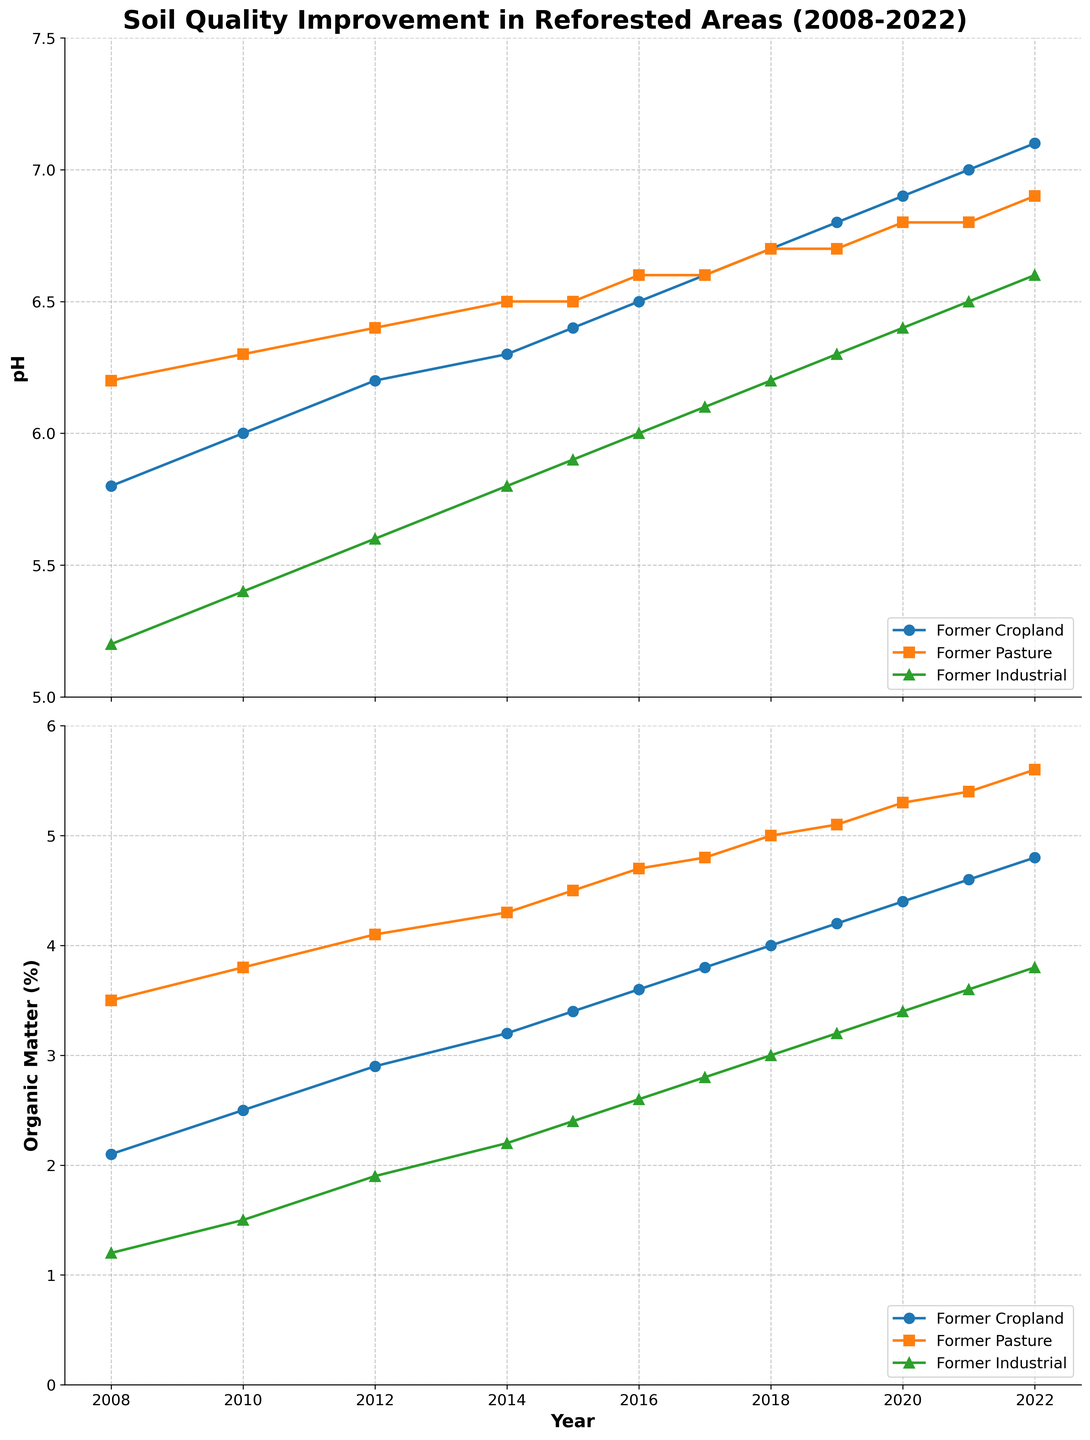What is the trend of soil pH in former cropland from 2008 to 2022? The trend can be observed by looking at the pH values on the line chart for former cropland over the years. The pH values start at 5.8 in 2008 and gradually increase each year, reaching 7.1 in 2022.
Answer: Increasing How does the organic matter percentage trend in former industrial areas from 2008 to 2022? To determine the trend, we observe the line representing the organic matter percentage in former industrial areas. It starts at 1.2% in 2008 and consistently rises each year, reaching 3.8% in 2022.
Answer: Increasing Which category had the highest increase in organic matter percentage from 2008 to 2022? To find this, we calculate the difference in organic matter percentage between 2008 and 2022 for each category. Former Cropland increased from 2.1% to 4.8% (2.7%), Former Pasture increased from 3.5% to 5.6% (2.1%), and Former Industrial increased from 1.2% to 3.8% (2.6%). Former Cropland shows the highest increase.
Answer: Former Cropland Between 2010 and 2014, which land use type showed the smallest change in pH values? We need to look at the pH values for each category in 2010 and 2014 and calculate the difference. Former Cropland: 6.0 to 6.3 (0.3), Former Pasture: 6.3 to 6.5 (0.2), Former Industrial: 5.4 to 5.8 (0.4). Former Pasture has the smallest change.
Answer: Former Pasture What was the pH of former industrial lands in 2015, and how does it compare to former pasturelands in the same year? Checking the pH values from the figure for both categories in 2015: Former Industrial is at 5.9, and Former Pasture is at 6.5. Comparing them, 5.9 is less than 6.5.
Answer: 5.9, less than In 2020, which land type had a higher percentage of organic matter, former cropland or former pasture? Referring to the 2020 data points, Former Cropland has an organic matter percentage of 4.4%, while Former Pasture has 5.3%. Hence, Former Pasture has a higher percentage.
Answer: Former Pasture What is the average pH of former cropland over the entire period from 2008 to 2022? Average pH is calculated by summing up all pH values of former cropland from 2008 to 2022 and dividing by the number of years: (5.8 + 6.0 + 6.2 + 6.3 + 6.4 + 6.5 + 6.6 + 6.7 + 6.8 + 6.9 + 7.0 + 7.1) / 12. The calculation gives (75.3 / 12) = 6.275.
Answer: 6.28 Compare the rate of change in organic matter percentage for former cropland between 2008-2012 and 2018-2022. Which period had a higher rate of increase? First, calculate the rate of change for each period: 
2008-2012: (2.9 - 2.1) / (2012 - 2008) = 0.8 / 4 = 0.2% per year. 
2018-2022: (4.8 - 4.0) / (2022 - 2018) = 0.8 / 4 = 0.2% per year. 
Both periods had the same rate of change.
Answer: Same rate Which category shows the least variation in pH values over the years? To determine the variation, the range (difference between the maximum and minimum values) for each category's pH needs to be calculated:
Former Cropland: Max 7.1, Min 5.8, Range = 1.3
Former Pasture: Max 6.9, Min 6.2, Range = 0.7
Former Industrial: Max 6.6, Min 5.2, Range = 1.4. 
Former Pasture shows the least variation.
Answer: Former Pasture 